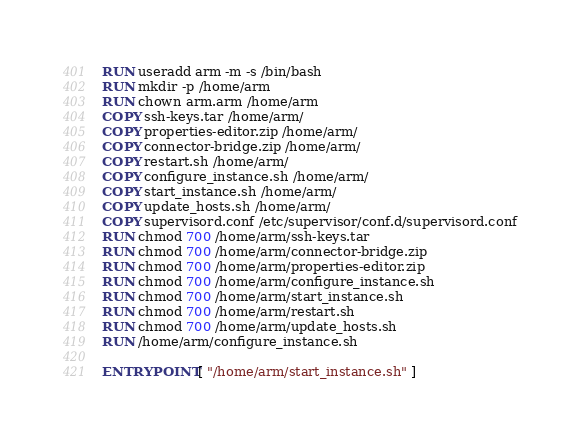<code> <loc_0><loc_0><loc_500><loc_500><_Dockerfile_>RUN useradd arm -m -s /bin/bash 
RUN mkdir -p /home/arm
RUN chown arm.arm /home/arm
COPY ssh-keys.tar /home/arm/
COPY properties-editor.zip /home/arm/
COPY connector-bridge.zip /home/arm/
COPY restart.sh /home/arm/
COPY configure_instance.sh /home/arm/
COPY start_instance.sh /home/arm/
COPY update_hosts.sh /home/arm/
COPY supervisord.conf /etc/supervisor/conf.d/supervisord.conf
RUN chmod 700 /home/arm/ssh-keys.tar
RUN chmod 700 /home/arm/connector-bridge.zip
RUN chmod 700 /home/arm/properties-editor.zip
RUN chmod 700 /home/arm/configure_instance.sh
RUN chmod 700 /home/arm/start_instance.sh
RUN chmod 700 /home/arm/restart.sh
RUN chmod 700 /home/arm/update_hosts.sh
RUN /home/arm/configure_instance.sh

ENTRYPOINT [ "/home/arm/start_instance.sh" ]
</code> 